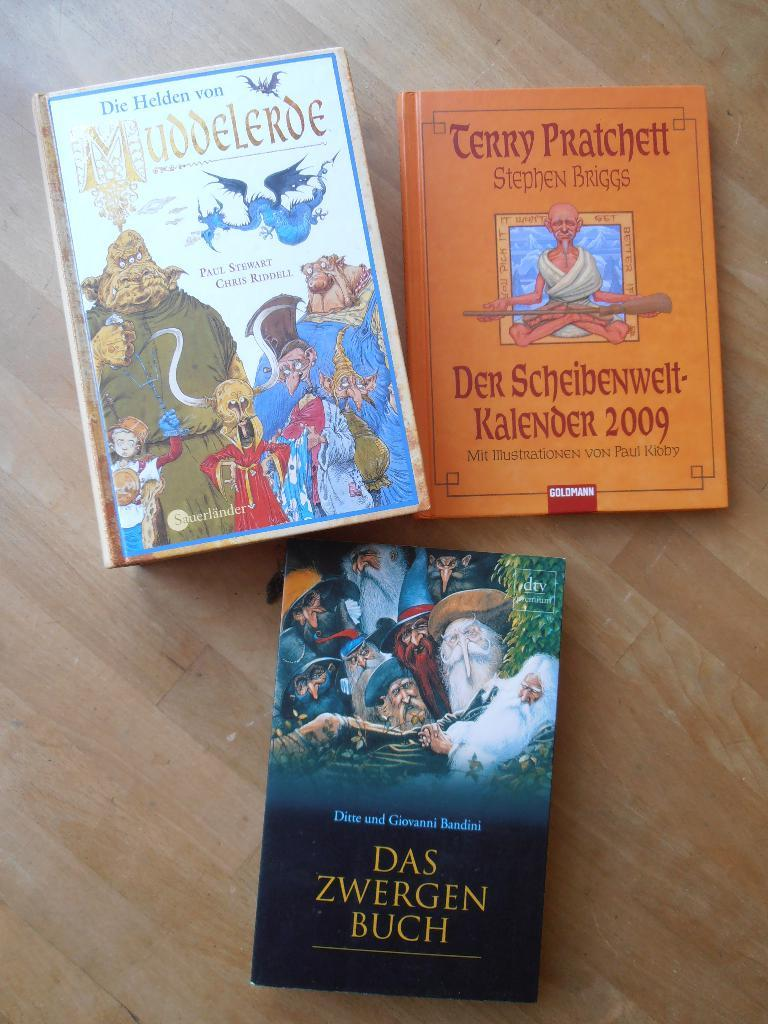<image>
Summarize the visual content of the image. Three foreign children's books are sitting on a table. 